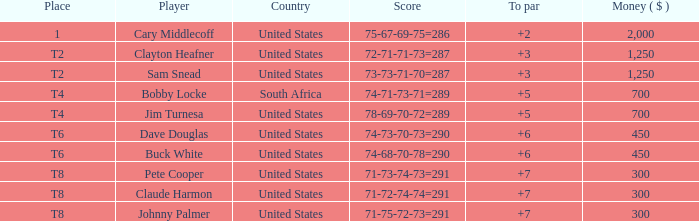What is the Johnny Palmer with a To larger than 6 Money sum? 300.0. 